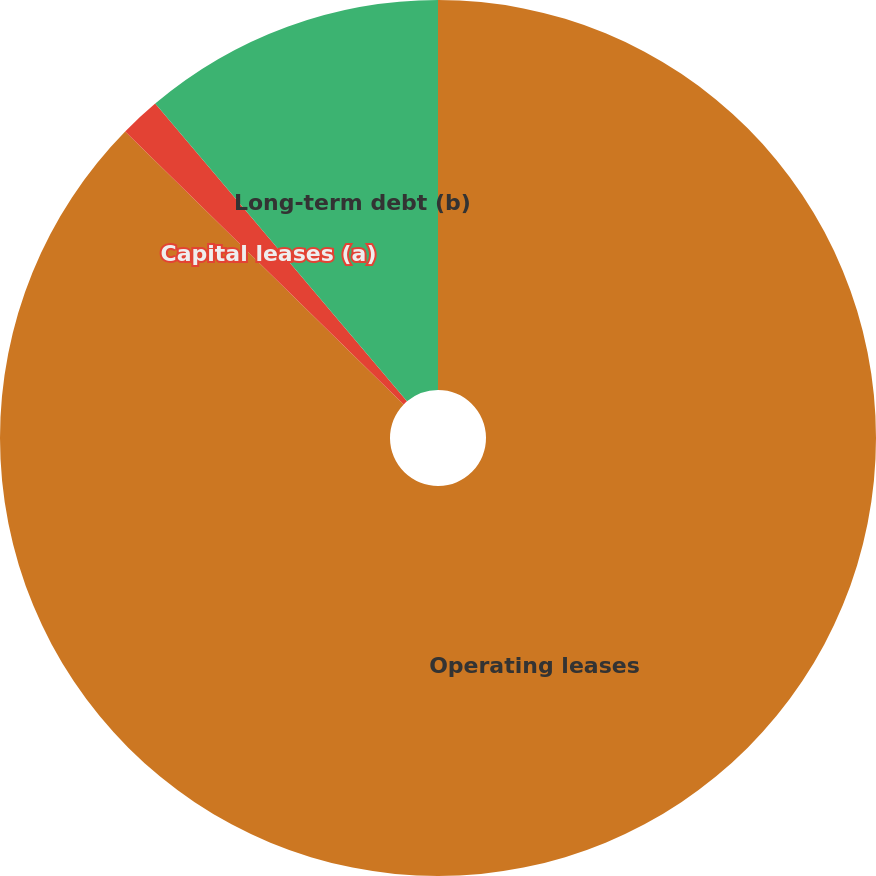Convert chart to OTSL. <chart><loc_0><loc_0><loc_500><loc_500><pie_chart><fcel>Operating leases<fcel>Capital leases (a)<fcel>Long-term debt (b)<nl><fcel>87.33%<fcel>1.49%<fcel>11.17%<nl></chart> 